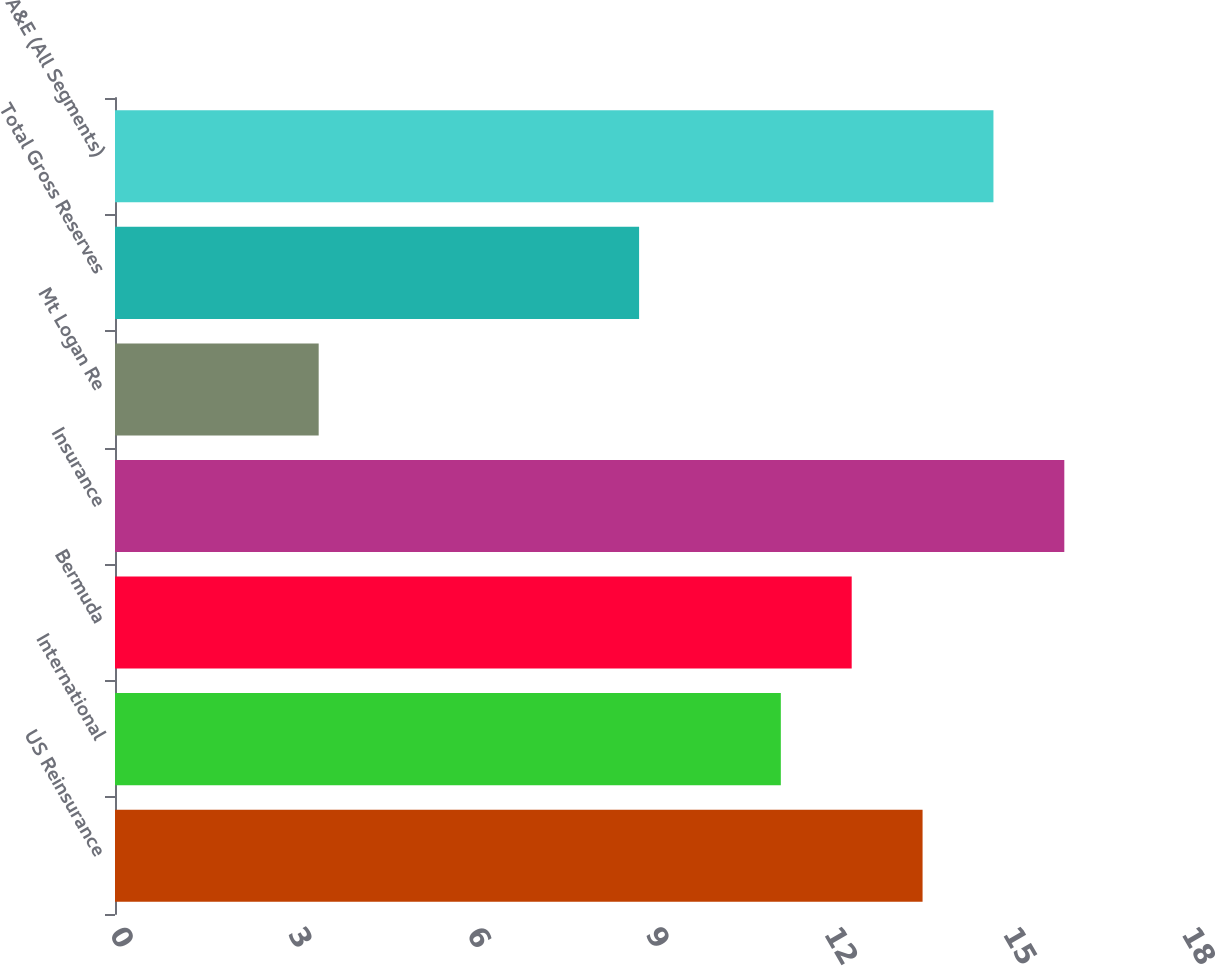<chart> <loc_0><loc_0><loc_500><loc_500><bar_chart><fcel>US Reinsurance<fcel>International<fcel>Bermuda<fcel>Insurance<fcel>Mt Logan Re<fcel>Total Gross Reserves<fcel>A&E (All Segments)<nl><fcel>13.56<fcel>11.18<fcel>12.37<fcel>15.94<fcel>3.42<fcel>8.8<fcel>14.75<nl></chart> 